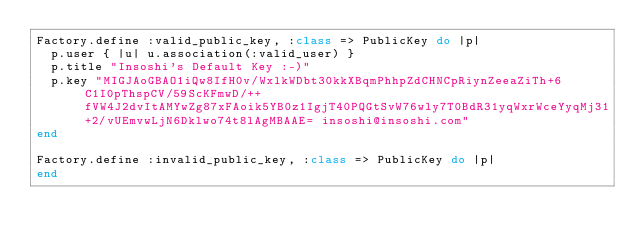Convert code to text. <code><loc_0><loc_0><loc_500><loc_500><_Ruby_>Factory.define :valid_public_key, :class => PublicKey do |p|
  p.user { |u| u.association(:valid_user) }
  p.title "Insoshi's Default Key :-)"
  p.key "MIGJAoGBAO1iQw8IfH0v/WxlkWDbt30kkXBqmPhhpZdCHNCpRiynZeeaZiTh+6C1I0pThspCV/59ScKFmwD/++fVW4J2dvItAMYwZg87xFAoik5YB0z1IgjT40PQGtSvW76wly7T0BdR31yqWxrWceYyqMj31+2/vUEmvwLjN6Dklwo74t8lAgMBAAE= insoshi@insoshi.com"
end

Factory.define :invalid_public_key, :class => PublicKey do |p|
end</code> 